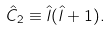Convert formula to latex. <formula><loc_0><loc_0><loc_500><loc_500>\hat { C } _ { 2 } \equiv \hat { l } ( \hat { l } + 1 ) .</formula> 